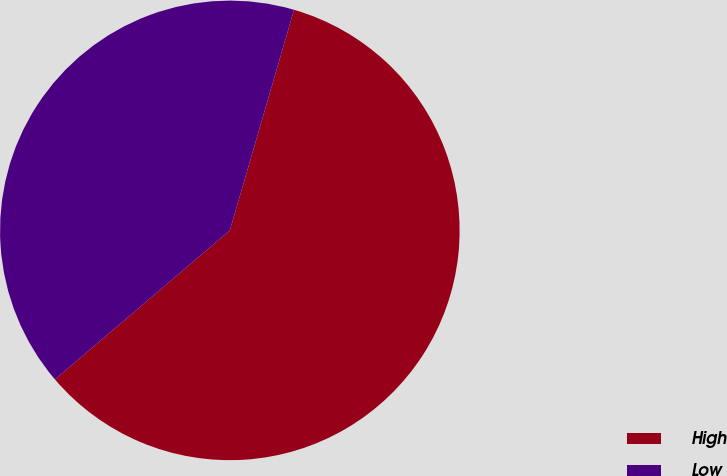Convert chart to OTSL. <chart><loc_0><loc_0><loc_500><loc_500><pie_chart><fcel>High<fcel>Low<nl><fcel>59.26%<fcel>40.74%<nl></chart> 